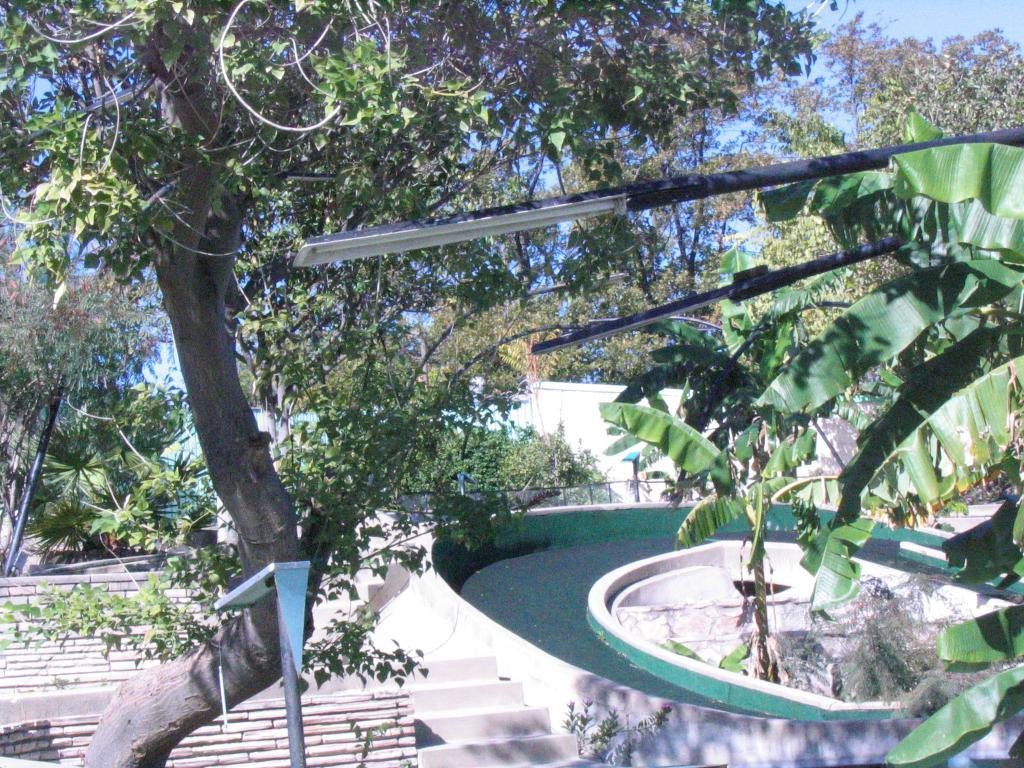What type of architectural feature is present in the image? There are steps in the image. What else can be seen in the image besides the steps? There is a wall, trees, and a fence in the image. What is visible in the background of the image? The sky is visible in the background of the image. Can you tell me how many rifles are leaning against the wall in the image? There are no rifles present in the image; it features steps, a wall, trees, and a fence. What type of class is being held in the image? There is no class being held in the image; it is an outdoor scene with steps, a wall, trees, and a fence. 